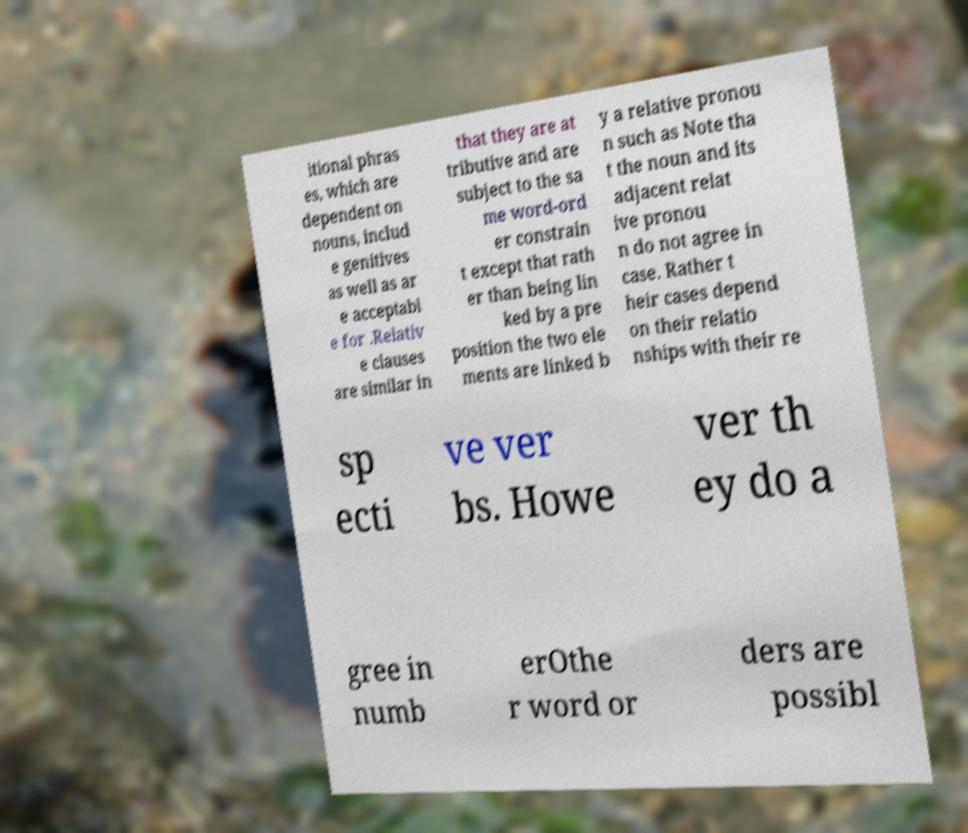Could you extract and type out the text from this image? itional phras es, which are dependent on nouns, includ e genitives as well as ar e acceptabl e for .Relativ e clauses are similar in that they are at tributive and are subject to the sa me word-ord er constrain t except that rath er than being lin ked by a pre position the two ele ments are linked b y a relative pronou n such as Note tha t the noun and its adjacent relat ive pronou n do not agree in case. Rather t heir cases depend on their relatio nships with their re sp ecti ve ver bs. Howe ver th ey do a gree in numb erOthe r word or ders are possibl 